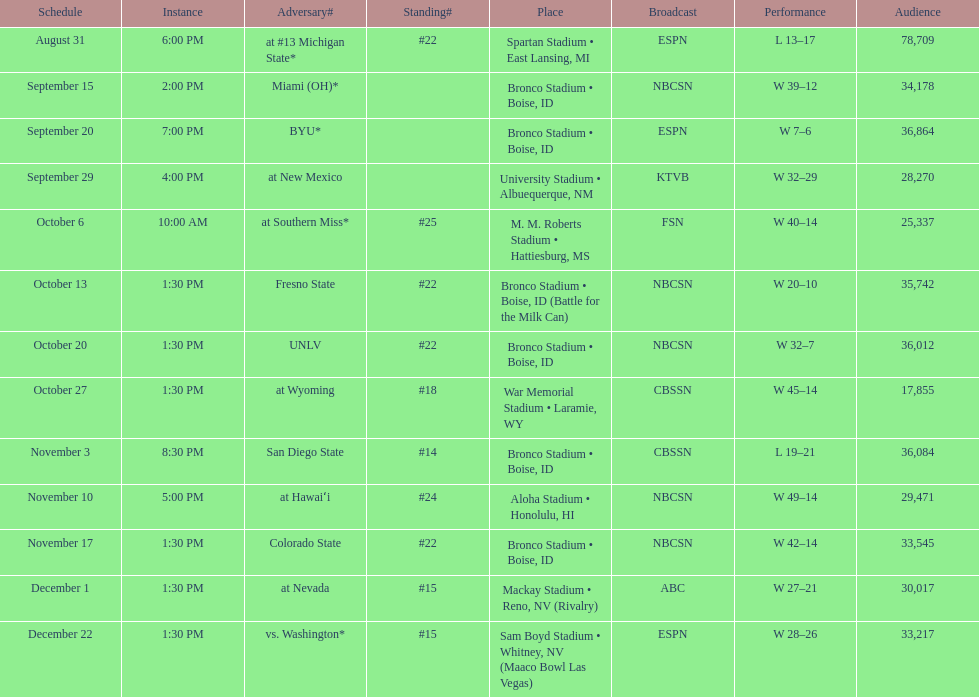What is the total number of games played at bronco stadium? 6. 